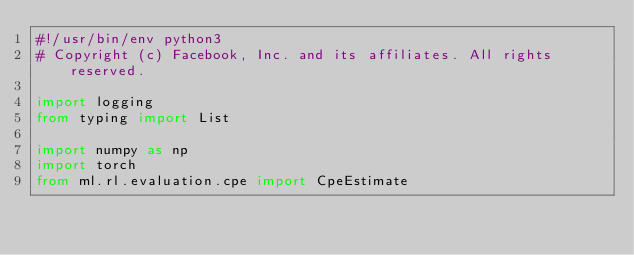Convert code to text. <code><loc_0><loc_0><loc_500><loc_500><_Python_>#!/usr/bin/env python3
# Copyright (c) Facebook, Inc. and its affiliates. All rights reserved.

import logging
from typing import List

import numpy as np
import torch
from ml.rl.evaluation.cpe import CpeEstimate</code> 